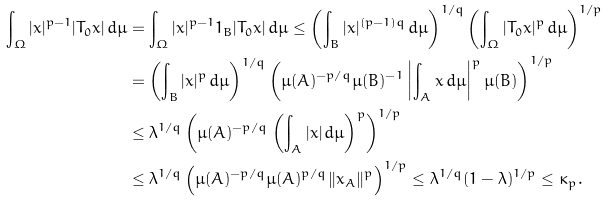Convert formula to latex. <formula><loc_0><loc_0><loc_500><loc_500>\int _ { \Omega } | x | ^ { p - 1 } | T _ { 0 } x | \, d \mu & = \int _ { \Omega } | x | ^ { p - 1 } 1 _ { B } | T _ { 0 } x | \, d \mu \leq \left ( \int _ { B } | x | ^ { ( p - 1 ) q } \, d \mu \right ) ^ { 1 / q } \left ( \int _ { \Omega } | T _ { 0 } x | ^ { p } \, d \mu \right ) ^ { 1 / p } \\ & = \left ( \int _ { B } | x | ^ { p } \, d \mu \right ) ^ { 1 / q } \left ( \mu ( A ) ^ { - p / q } \mu ( B ) ^ { - 1 } \left | \int _ { A } x \, d \mu \right | ^ { p } \mu ( B ) \right ) ^ { 1 / p } \\ & \leq \lambda ^ { 1 / q } \left ( \mu ( A ) ^ { - p / q } \left ( \int _ { A } | x | \, d \mu \right ) ^ { p } \right ) ^ { 1 / p } \\ & \leq \lambda ^ { 1 / q } \left ( \mu ( A ) ^ { - p / q } \mu ( A ) ^ { p / q } \| x _ { A } \| ^ { p } \right ) ^ { 1 / p } \leq \lambda ^ { 1 / q } ( 1 - \lambda ) ^ { 1 / p } \leq \kappa _ { p } .</formula> 